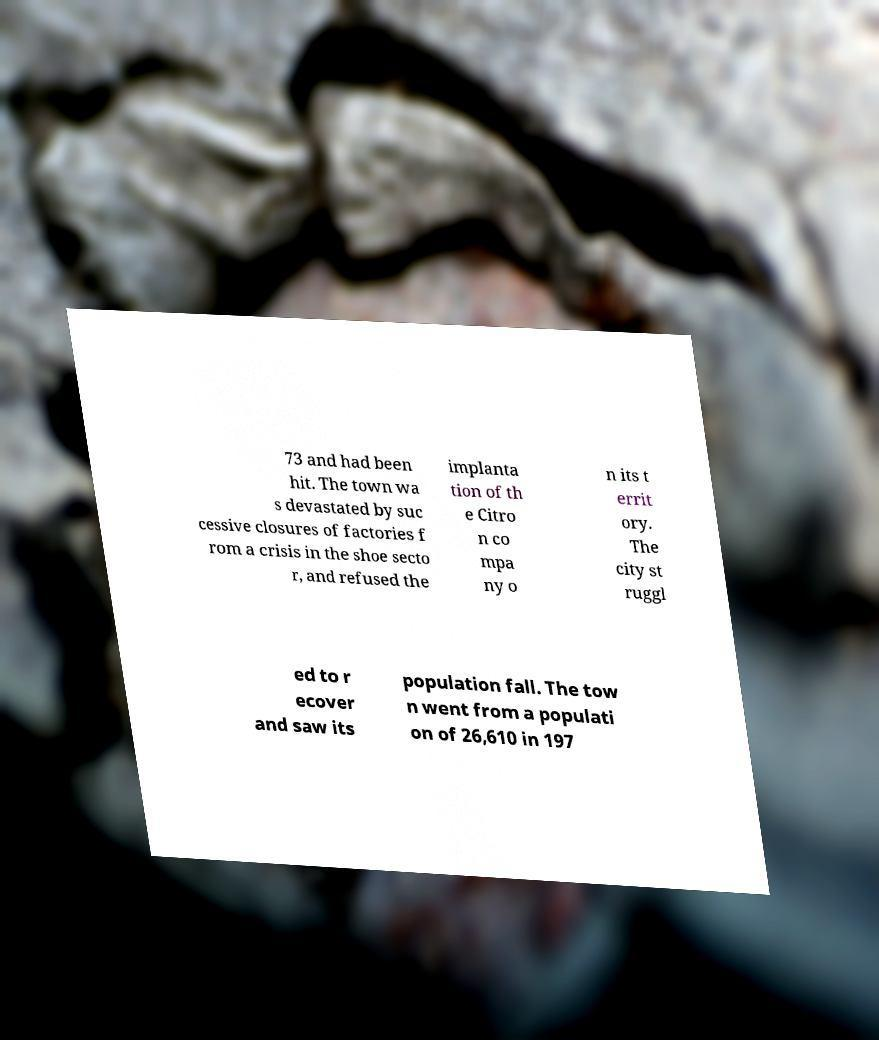Please read and relay the text visible in this image. What does it say? 73 and had been hit. The town wa s devastated by suc cessive closures of factories f rom a crisis in the shoe secto r, and refused the implanta tion of th e Citro n co mpa ny o n its t errit ory. The city st ruggl ed to r ecover and saw its population fall. The tow n went from a populati on of 26,610 in 197 